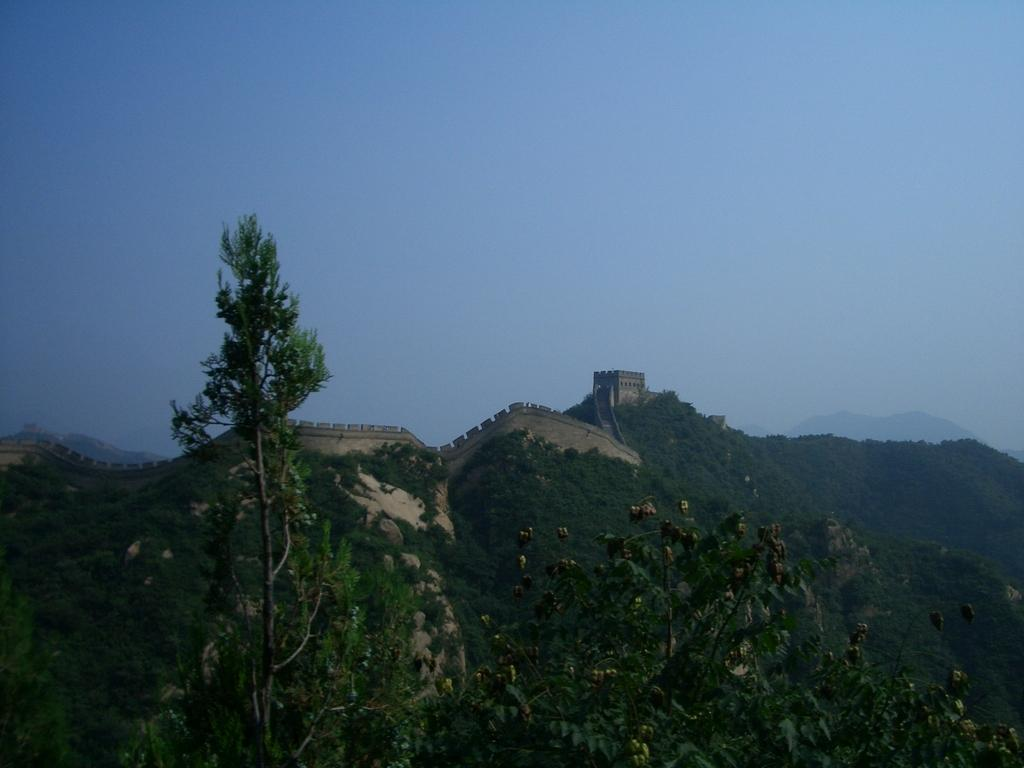What type of natural elements can be seen in the image? There are trees in the image. What type of geographical features are present in the image? There are mountains in the image. Are there any man-made structures visible in the image? Yes, there is a building in the image. What can be seen in the background of the image? The sky is visible in the background of the image. Where are the ladybugs hiding on the shelf in the image? There are no ladybugs or shelves present in the image. What type of bushes can be seen near the trees in the image? There is no mention of bushes in the provided facts, so we cannot determine if they are present in the image. 